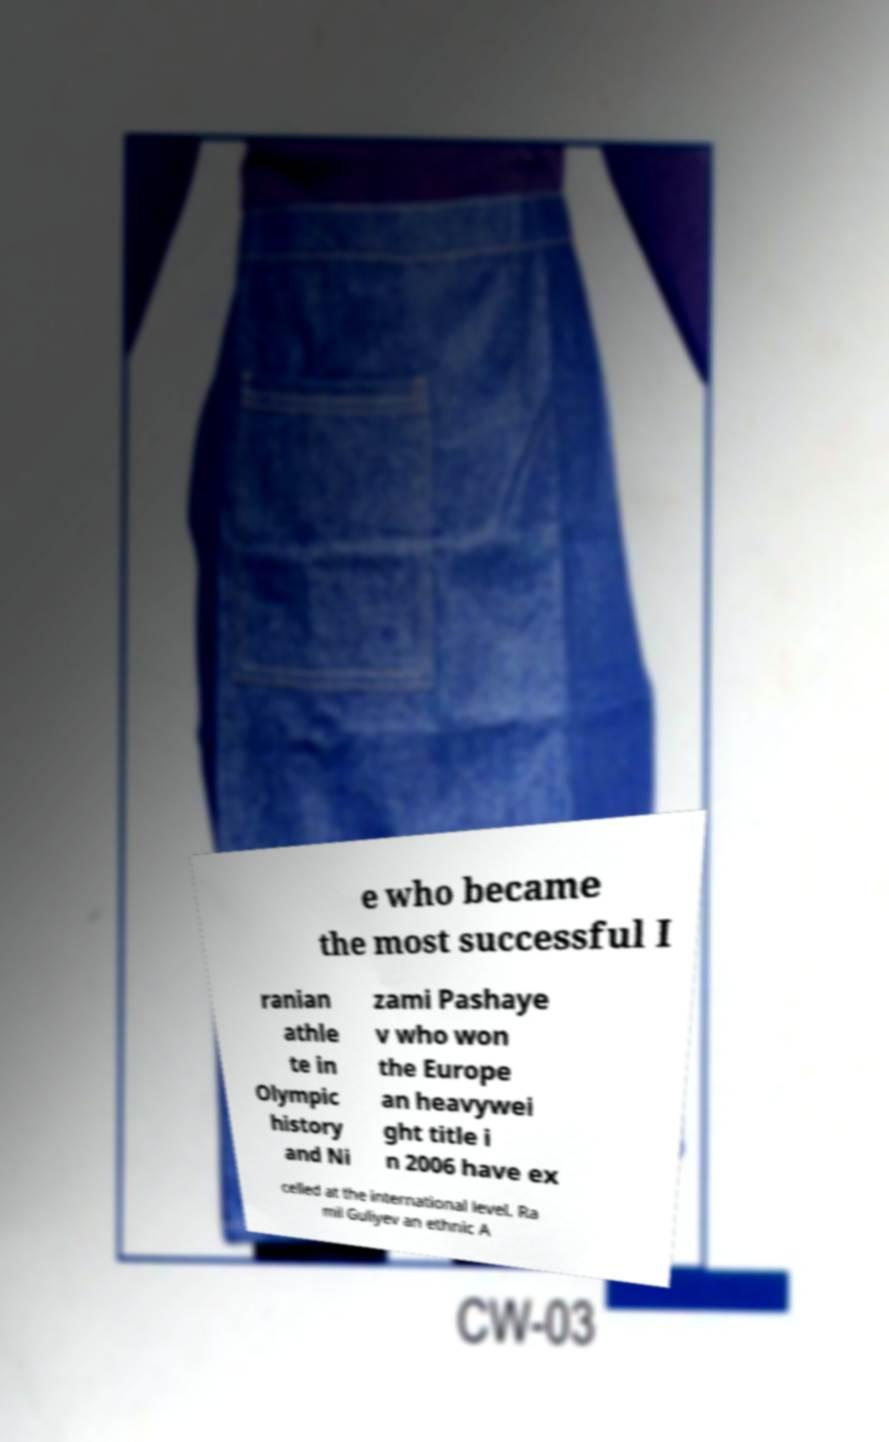What messages or text are displayed in this image? I need them in a readable, typed format. e who became the most successful I ranian athle te in Olympic history and Ni zami Pashaye v who won the Europe an heavywei ght title i n 2006 have ex celled at the international level. Ra mil Guliyev an ethnic A 